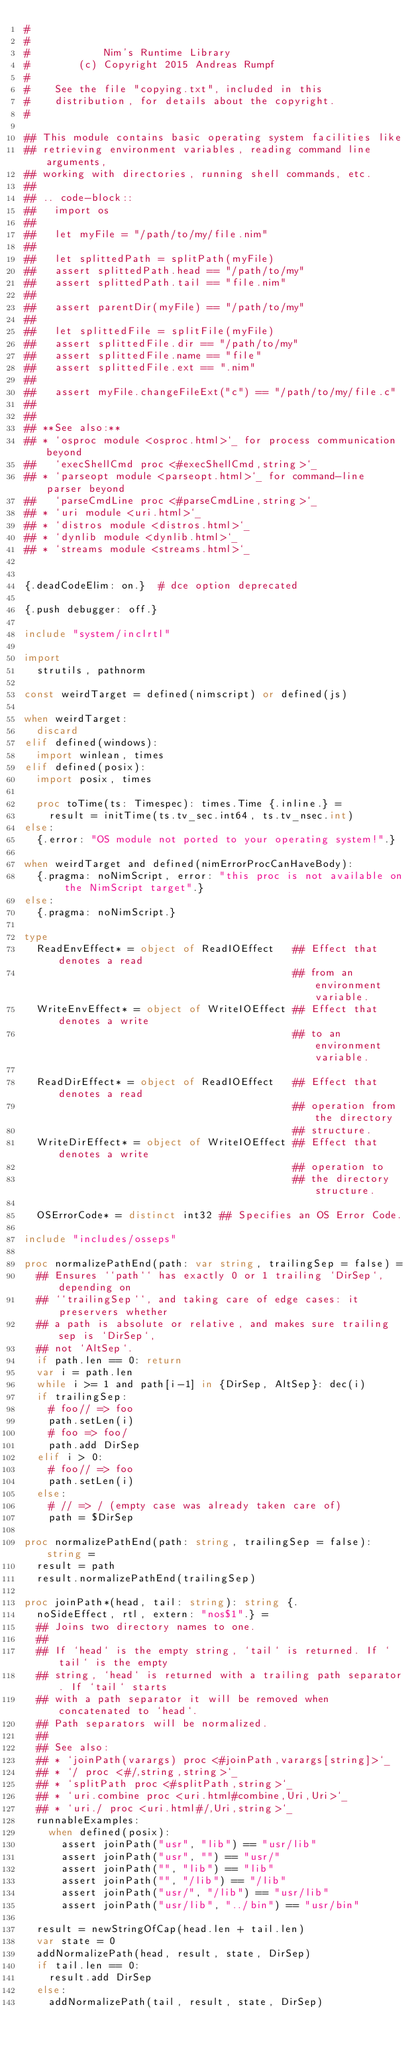Convert code to text. <code><loc_0><loc_0><loc_500><loc_500><_Nim_>#
#
#            Nim's Runtime Library
#        (c) Copyright 2015 Andreas Rumpf
#
#    See the file "copying.txt", included in this
#    distribution, for details about the copyright.
#

## This module contains basic operating system facilities like
## retrieving environment variables, reading command line arguments,
## working with directories, running shell commands, etc.
##
## .. code-block::
##   import os
##
##   let myFile = "/path/to/my/file.nim"
##
##   let splittedPath = splitPath(myFile)
##   assert splittedPath.head == "/path/to/my"
##   assert splittedPath.tail == "file.nim"
##
##   assert parentDir(myFile) == "/path/to/my"
##
##   let splittedFile = splitFile(myFile)
##   assert splittedFile.dir == "/path/to/my"
##   assert splittedFile.name == "file"
##   assert splittedFile.ext == ".nim"
##
##   assert myFile.changeFileExt("c") == "/path/to/my/file.c"
##
##
## **See also:**
## * `osproc module <osproc.html>`_ for process communication beyond
##   `execShellCmd proc <#execShellCmd,string>`_
## * `parseopt module <parseopt.html>`_ for command-line parser beyond
##   `parseCmdLine proc <#parseCmdLine,string>`_
## * `uri module <uri.html>`_
## * `distros module <distros.html>`_
## * `dynlib module <dynlib.html>`_
## * `streams module <streams.html>`_


{.deadCodeElim: on.}  # dce option deprecated

{.push debugger: off.}

include "system/inclrtl"

import
  strutils, pathnorm

const weirdTarget = defined(nimscript) or defined(js)

when weirdTarget:
  discard
elif defined(windows):
  import winlean, times
elif defined(posix):
  import posix, times

  proc toTime(ts: Timespec): times.Time {.inline.} =
    result = initTime(ts.tv_sec.int64, ts.tv_nsec.int)
else:
  {.error: "OS module not ported to your operating system!".}

when weirdTarget and defined(nimErrorProcCanHaveBody):
  {.pragma: noNimScript, error: "this proc is not available on the NimScript target".}
else:
  {.pragma: noNimScript.}

type
  ReadEnvEffect* = object of ReadIOEffect   ## Effect that denotes a read
                                            ## from an environment variable.
  WriteEnvEffect* = object of WriteIOEffect ## Effect that denotes a write
                                            ## to an environment variable.

  ReadDirEffect* = object of ReadIOEffect   ## Effect that denotes a read
                                            ## operation from the directory
                                            ## structure.
  WriteDirEffect* = object of WriteIOEffect ## Effect that denotes a write
                                            ## operation to
                                            ## the directory structure.

  OSErrorCode* = distinct int32 ## Specifies an OS Error Code.

include "includes/osseps"

proc normalizePathEnd(path: var string, trailingSep = false) =
  ## Ensures ``path`` has exactly 0 or 1 trailing `DirSep`, depending on
  ## ``trailingSep``, and taking care of edge cases: it preservers whether
  ## a path is absolute or relative, and makes sure trailing sep is `DirSep`,
  ## not `AltSep`.
  if path.len == 0: return
  var i = path.len
  while i >= 1 and path[i-1] in {DirSep, AltSep}: dec(i)
  if trailingSep:
    # foo// => foo
    path.setLen(i)
    # foo => foo/
    path.add DirSep
  elif i > 0:
    # foo// => foo
    path.setLen(i)
  else:
    # // => / (empty case was already taken care of)
    path = $DirSep

proc normalizePathEnd(path: string, trailingSep = false): string =
  result = path
  result.normalizePathEnd(trailingSep)

proc joinPath*(head, tail: string): string {.
  noSideEffect, rtl, extern: "nos$1".} =
  ## Joins two directory names to one.
  ##
  ## If `head` is the empty string, `tail` is returned. If `tail` is the empty
  ## string, `head` is returned with a trailing path separator. If `tail` starts
  ## with a path separator it will be removed when concatenated to `head`.
  ## Path separators will be normalized.
  ##
  ## See also:
  ## * `joinPath(varargs) proc <#joinPath,varargs[string]>`_
  ## * `/ proc <#/,string,string>`_
  ## * `splitPath proc <#splitPath,string>`_
  ## * `uri.combine proc <uri.html#combine,Uri,Uri>`_
  ## * `uri./ proc <uri.html#/,Uri,string>`_
  runnableExamples:
    when defined(posix):
      assert joinPath("usr", "lib") == "usr/lib"
      assert joinPath("usr", "") == "usr/"
      assert joinPath("", "lib") == "lib"
      assert joinPath("", "/lib") == "/lib"
      assert joinPath("usr/", "/lib") == "usr/lib"
      assert joinPath("usr/lib", "../bin") == "usr/bin"

  result = newStringOfCap(head.len + tail.len)
  var state = 0
  addNormalizePath(head, result, state, DirSep)
  if tail.len == 0:
    result.add DirSep
  else:
    addNormalizePath(tail, result, state, DirSep)</code> 